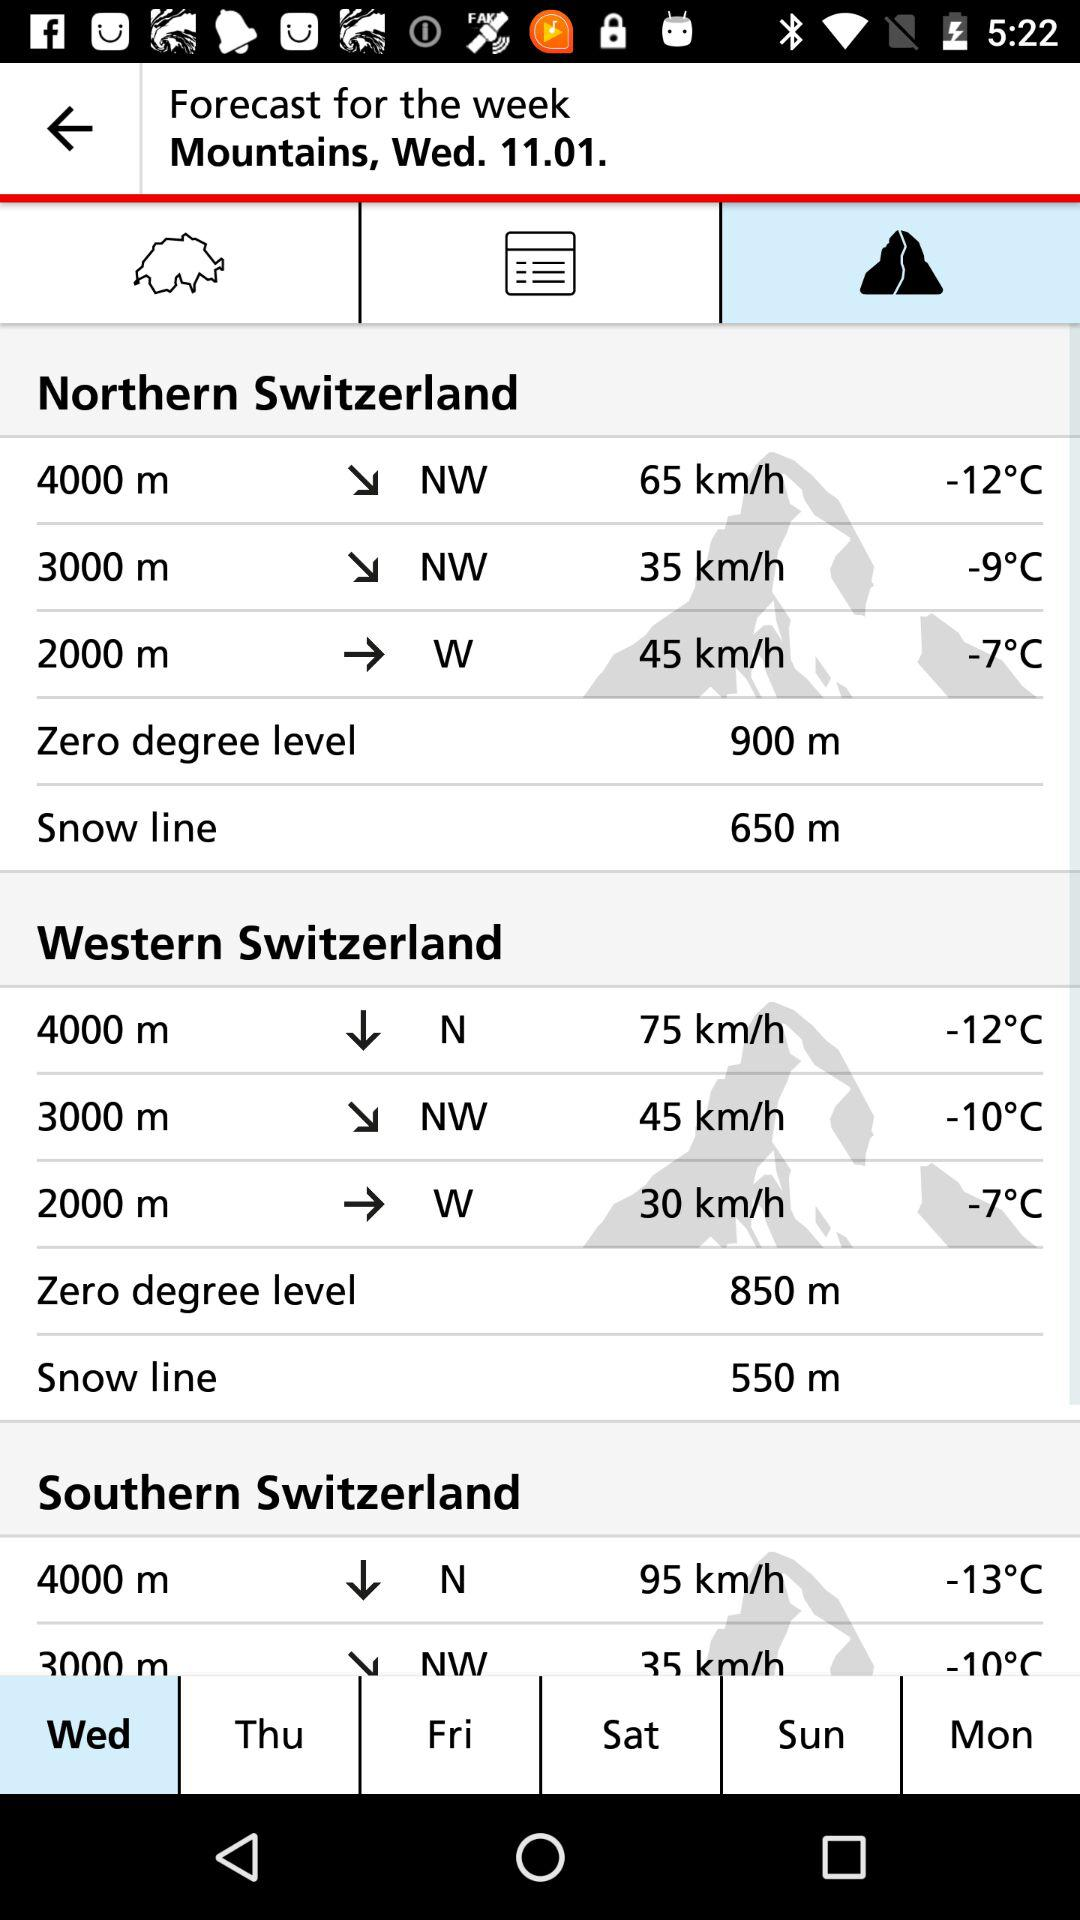How many degrees colder is it at 4000m in northern Switzerland than at 3000m?
Answer the question using a single word or phrase. 3 